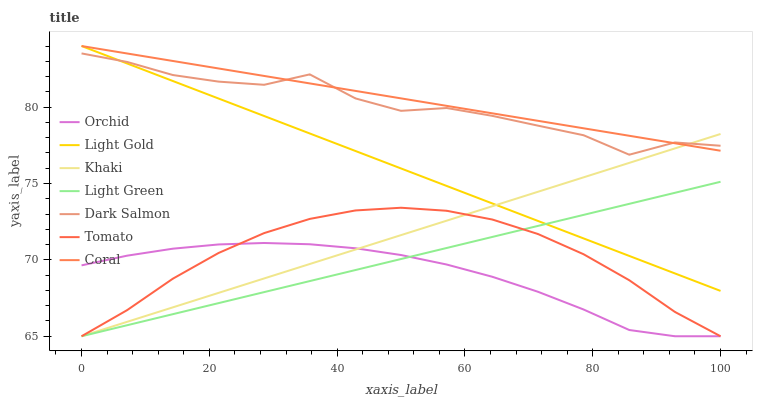Does Orchid have the minimum area under the curve?
Answer yes or no. Yes. Does Coral have the maximum area under the curve?
Answer yes or no. Yes. Does Khaki have the minimum area under the curve?
Answer yes or no. No. Does Khaki have the maximum area under the curve?
Answer yes or no. No. Is Light Green the smoothest?
Answer yes or no. Yes. Is Dark Salmon the roughest?
Answer yes or no. Yes. Is Khaki the smoothest?
Answer yes or no. No. Is Khaki the roughest?
Answer yes or no. No. Does Tomato have the lowest value?
Answer yes or no. Yes. Does Coral have the lowest value?
Answer yes or no. No. Does Light Gold have the highest value?
Answer yes or no. Yes. Does Khaki have the highest value?
Answer yes or no. No. Is Tomato less than Light Gold?
Answer yes or no. Yes. Is Coral greater than Light Green?
Answer yes or no. Yes. Does Tomato intersect Light Green?
Answer yes or no. Yes. Is Tomato less than Light Green?
Answer yes or no. No. Is Tomato greater than Light Green?
Answer yes or no. No. Does Tomato intersect Light Gold?
Answer yes or no. No. 